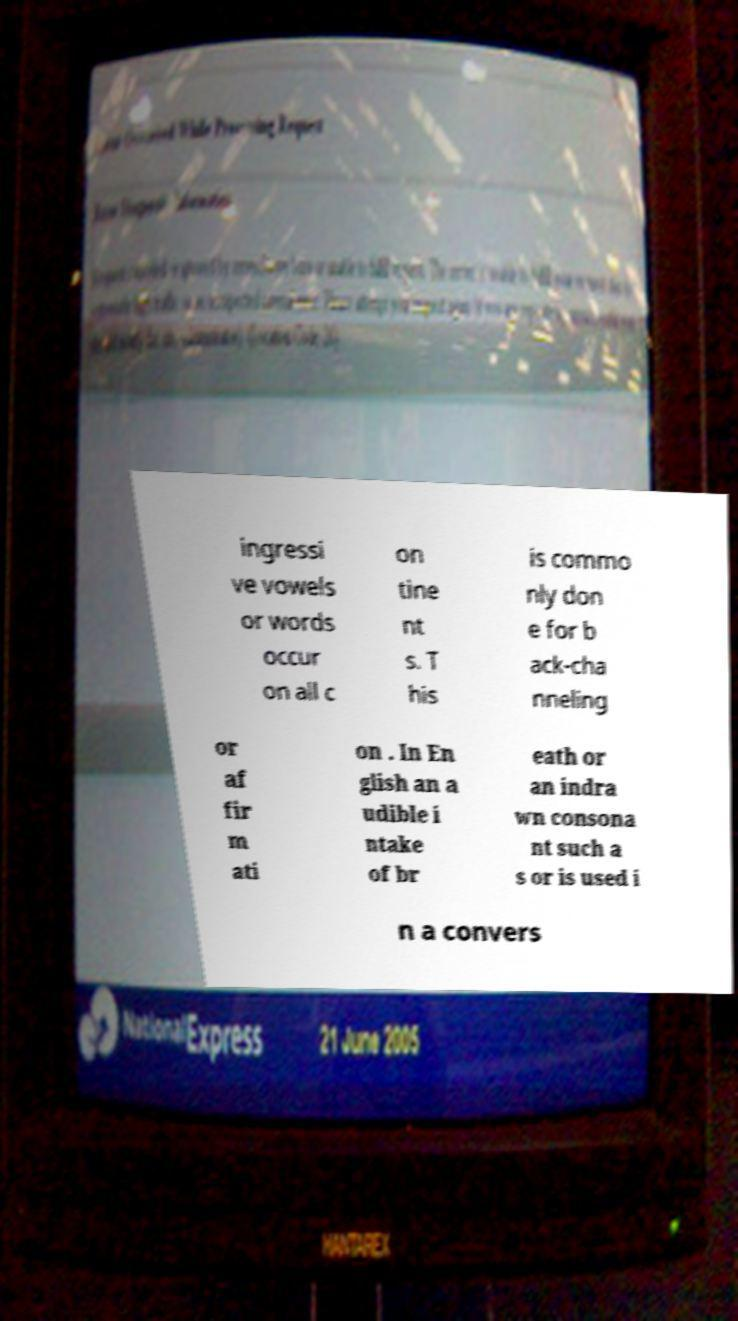For documentation purposes, I need the text within this image transcribed. Could you provide that? ingressi ve vowels or words occur on all c on tine nt s. T his is commo nly don e for b ack-cha nneling or af fir m ati on . In En glish an a udible i ntake of br eath or an indra wn consona nt such a s or is used i n a convers 